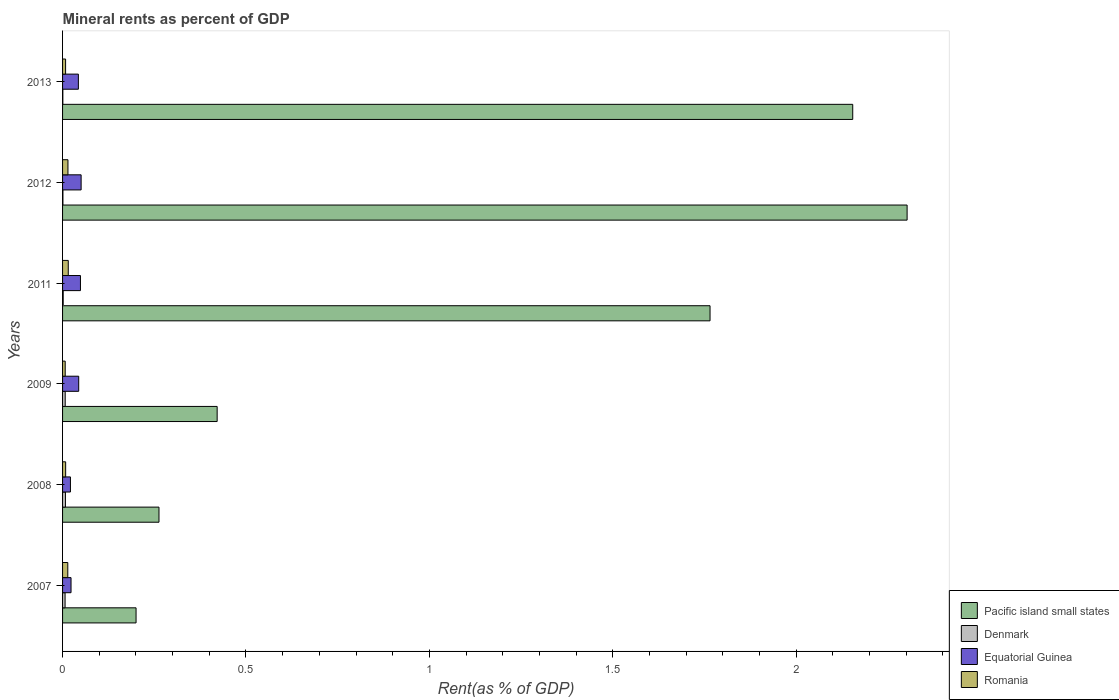Are the number of bars per tick equal to the number of legend labels?
Give a very brief answer. Yes. Are the number of bars on each tick of the Y-axis equal?
Ensure brevity in your answer.  Yes. How many bars are there on the 6th tick from the bottom?
Offer a very short reply. 4. What is the mineral rent in Pacific island small states in 2013?
Your response must be concise. 2.15. Across all years, what is the maximum mineral rent in Equatorial Guinea?
Offer a terse response. 0.05. Across all years, what is the minimum mineral rent in Equatorial Guinea?
Offer a very short reply. 0.02. In which year was the mineral rent in Denmark maximum?
Give a very brief answer. 2008. What is the total mineral rent in Denmark in the graph?
Provide a succinct answer. 0.03. What is the difference between the mineral rent in Pacific island small states in 2012 and that in 2013?
Give a very brief answer. 0.15. What is the difference between the mineral rent in Romania in 2009 and the mineral rent in Pacific island small states in 2007?
Your answer should be very brief. -0.19. What is the average mineral rent in Pacific island small states per year?
Offer a very short reply. 1.18. In the year 2008, what is the difference between the mineral rent in Pacific island small states and mineral rent in Equatorial Guinea?
Offer a very short reply. 0.24. In how many years, is the mineral rent in Equatorial Guinea greater than 1 %?
Provide a succinct answer. 0. What is the ratio of the mineral rent in Pacific island small states in 2011 to that in 2013?
Your answer should be compact. 0.82. What is the difference between the highest and the second highest mineral rent in Equatorial Guinea?
Your answer should be very brief. 0. What is the difference between the highest and the lowest mineral rent in Romania?
Your answer should be very brief. 0.01. Is the sum of the mineral rent in Equatorial Guinea in 2008 and 2009 greater than the maximum mineral rent in Denmark across all years?
Your response must be concise. Yes. Is it the case that in every year, the sum of the mineral rent in Equatorial Guinea and mineral rent in Pacific island small states is greater than the sum of mineral rent in Romania and mineral rent in Denmark?
Give a very brief answer. Yes. What does the 1st bar from the top in 2012 represents?
Your answer should be compact. Romania. What does the 1st bar from the bottom in 2007 represents?
Offer a very short reply. Pacific island small states. How many bars are there?
Provide a succinct answer. 24. How many years are there in the graph?
Offer a terse response. 6. Are the values on the major ticks of X-axis written in scientific E-notation?
Provide a short and direct response. No. Does the graph contain grids?
Provide a short and direct response. No. Where does the legend appear in the graph?
Make the answer very short. Bottom right. What is the title of the graph?
Keep it short and to the point. Mineral rents as percent of GDP. What is the label or title of the X-axis?
Offer a terse response. Rent(as % of GDP). What is the Rent(as % of GDP) in Pacific island small states in 2007?
Make the answer very short. 0.2. What is the Rent(as % of GDP) of Denmark in 2007?
Provide a short and direct response. 0.01. What is the Rent(as % of GDP) of Equatorial Guinea in 2007?
Provide a succinct answer. 0.02. What is the Rent(as % of GDP) of Romania in 2007?
Offer a terse response. 0.01. What is the Rent(as % of GDP) in Pacific island small states in 2008?
Keep it short and to the point. 0.26. What is the Rent(as % of GDP) in Denmark in 2008?
Keep it short and to the point. 0.01. What is the Rent(as % of GDP) of Equatorial Guinea in 2008?
Offer a very short reply. 0.02. What is the Rent(as % of GDP) in Romania in 2008?
Keep it short and to the point. 0.01. What is the Rent(as % of GDP) of Pacific island small states in 2009?
Provide a short and direct response. 0.42. What is the Rent(as % of GDP) in Denmark in 2009?
Provide a succinct answer. 0.01. What is the Rent(as % of GDP) in Equatorial Guinea in 2009?
Provide a short and direct response. 0.04. What is the Rent(as % of GDP) in Romania in 2009?
Ensure brevity in your answer.  0.01. What is the Rent(as % of GDP) of Pacific island small states in 2011?
Offer a very short reply. 1.77. What is the Rent(as % of GDP) in Denmark in 2011?
Provide a succinct answer. 0. What is the Rent(as % of GDP) in Equatorial Guinea in 2011?
Give a very brief answer. 0.05. What is the Rent(as % of GDP) of Romania in 2011?
Ensure brevity in your answer.  0.02. What is the Rent(as % of GDP) in Pacific island small states in 2012?
Your answer should be compact. 2.3. What is the Rent(as % of GDP) in Denmark in 2012?
Keep it short and to the point. 0. What is the Rent(as % of GDP) in Equatorial Guinea in 2012?
Provide a short and direct response. 0.05. What is the Rent(as % of GDP) of Romania in 2012?
Provide a short and direct response. 0.01. What is the Rent(as % of GDP) of Pacific island small states in 2013?
Offer a very short reply. 2.15. What is the Rent(as % of GDP) in Denmark in 2013?
Provide a short and direct response. 0. What is the Rent(as % of GDP) in Equatorial Guinea in 2013?
Offer a very short reply. 0.04. What is the Rent(as % of GDP) of Romania in 2013?
Provide a short and direct response. 0.01. Across all years, what is the maximum Rent(as % of GDP) of Pacific island small states?
Your response must be concise. 2.3. Across all years, what is the maximum Rent(as % of GDP) in Denmark?
Your answer should be very brief. 0.01. Across all years, what is the maximum Rent(as % of GDP) of Equatorial Guinea?
Your answer should be compact. 0.05. Across all years, what is the maximum Rent(as % of GDP) of Romania?
Offer a terse response. 0.02. Across all years, what is the minimum Rent(as % of GDP) in Pacific island small states?
Give a very brief answer. 0.2. Across all years, what is the minimum Rent(as % of GDP) of Denmark?
Your answer should be very brief. 0. Across all years, what is the minimum Rent(as % of GDP) of Equatorial Guinea?
Provide a succinct answer. 0.02. Across all years, what is the minimum Rent(as % of GDP) of Romania?
Provide a succinct answer. 0.01. What is the total Rent(as % of GDP) of Pacific island small states in the graph?
Ensure brevity in your answer.  7.11. What is the total Rent(as % of GDP) in Denmark in the graph?
Your answer should be very brief. 0.03. What is the total Rent(as % of GDP) of Equatorial Guinea in the graph?
Keep it short and to the point. 0.23. What is the total Rent(as % of GDP) in Romania in the graph?
Ensure brevity in your answer.  0.07. What is the difference between the Rent(as % of GDP) of Pacific island small states in 2007 and that in 2008?
Your answer should be very brief. -0.06. What is the difference between the Rent(as % of GDP) of Denmark in 2007 and that in 2008?
Give a very brief answer. -0. What is the difference between the Rent(as % of GDP) of Equatorial Guinea in 2007 and that in 2008?
Keep it short and to the point. 0. What is the difference between the Rent(as % of GDP) of Romania in 2007 and that in 2008?
Give a very brief answer. 0.01. What is the difference between the Rent(as % of GDP) of Pacific island small states in 2007 and that in 2009?
Provide a succinct answer. -0.22. What is the difference between the Rent(as % of GDP) in Denmark in 2007 and that in 2009?
Your answer should be compact. -0. What is the difference between the Rent(as % of GDP) in Equatorial Guinea in 2007 and that in 2009?
Keep it short and to the point. -0.02. What is the difference between the Rent(as % of GDP) of Romania in 2007 and that in 2009?
Ensure brevity in your answer.  0.01. What is the difference between the Rent(as % of GDP) of Pacific island small states in 2007 and that in 2011?
Provide a succinct answer. -1.56. What is the difference between the Rent(as % of GDP) of Denmark in 2007 and that in 2011?
Provide a short and direct response. 0.01. What is the difference between the Rent(as % of GDP) in Equatorial Guinea in 2007 and that in 2011?
Ensure brevity in your answer.  -0.03. What is the difference between the Rent(as % of GDP) in Romania in 2007 and that in 2011?
Offer a terse response. -0. What is the difference between the Rent(as % of GDP) of Pacific island small states in 2007 and that in 2012?
Offer a very short reply. -2.1. What is the difference between the Rent(as % of GDP) of Denmark in 2007 and that in 2012?
Give a very brief answer. 0.01. What is the difference between the Rent(as % of GDP) of Equatorial Guinea in 2007 and that in 2012?
Offer a very short reply. -0.03. What is the difference between the Rent(as % of GDP) of Romania in 2007 and that in 2012?
Offer a terse response. -0. What is the difference between the Rent(as % of GDP) in Pacific island small states in 2007 and that in 2013?
Give a very brief answer. -1.95. What is the difference between the Rent(as % of GDP) of Denmark in 2007 and that in 2013?
Keep it short and to the point. 0.01. What is the difference between the Rent(as % of GDP) of Equatorial Guinea in 2007 and that in 2013?
Keep it short and to the point. -0.02. What is the difference between the Rent(as % of GDP) of Romania in 2007 and that in 2013?
Your answer should be very brief. 0.01. What is the difference between the Rent(as % of GDP) in Pacific island small states in 2008 and that in 2009?
Offer a terse response. -0.16. What is the difference between the Rent(as % of GDP) of Denmark in 2008 and that in 2009?
Make the answer very short. 0. What is the difference between the Rent(as % of GDP) of Equatorial Guinea in 2008 and that in 2009?
Offer a terse response. -0.02. What is the difference between the Rent(as % of GDP) in Romania in 2008 and that in 2009?
Your response must be concise. 0. What is the difference between the Rent(as % of GDP) in Pacific island small states in 2008 and that in 2011?
Keep it short and to the point. -1.5. What is the difference between the Rent(as % of GDP) of Denmark in 2008 and that in 2011?
Your answer should be compact. 0.01. What is the difference between the Rent(as % of GDP) of Equatorial Guinea in 2008 and that in 2011?
Keep it short and to the point. -0.03. What is the difference between the Rent(as % of GDP) of Romania in 2008 and that in 2011?
Offer a very short reply. -0.01. What is the difference between the Rent(as % of GDP) of Pacific island small states in 2008 and that in 2012?
Give a very brief answer. -2.04. What is the difference between the Rent(as % of GDP) of Denmark in 2008 and that in 2012?
Keep it short and to the point. 0.01. What is the difference between the Rent(as % of GDP) in Equatorial Guinea in 2008 and that in 2012?
Your answer should be very brief. -0.03. What is the difference between the Rent(as % of GDP) of Romania in 2008 and that in 2012?
Keep it short and to the point. -0.01. What is the difference between the Rent(as % of GDP) in Pacific island small states in 2008 and that in 2013?
Your answer should be compact. -1.89. What is the difference between the Rent(as % of GDP) in Denmark in 2008 and that in 2013?
Provide a short and direct response. 0.01. What is the difference between the Rent(as % of GDP) of Equatorial Guinea in 2008 and that in 2013?
Give a very brief answer. -0.02. What is the difference between the Rent(as % of GDP) in Pacific island small states in 2009 and that in 2011?
Make the answer very short. -1.34. What is the difference between the Rent(as % of GDP) of Denmark in 2009 and that in 2011?
Your answer should be very brief. 0.01. What is the difference between the Rent(as % of GDP) of Equatorial Guinea in 2009 and that in 2011?
Offer a terse response. -0. What is the difference between the Rent(as % of GDP) in Romania in 2009 and that in 2011?
Offer a terse response. -0.01. What is the difference between the Rent(as % of GDP) in Pacific island small states in 2009 and that in 2012?
Your response must be concise. -1.88. What is the difference between the Rent(as % of GDP) of Denmark in 2009 and that in 2012?
Keep it short and to the point. 0.01. What is the difference between the Rent(as % of GDP) in Equatorial Guinea in 2009 and that in 2012?
Your answer should be very brief. -0.01. What is the difference between the Rent(as % of GDP) in Romania in 2009 and that in 2012?
Keep it short and to the point. -0.01. What is the difference between the Rent(as % of GDP) in Pacific island small states in 2009 and that in 2013?
Give a very brief answer. -1.73. What is the difference between the Rent(as % of GDP) in Denmark in 2009 and that in 2013?
Offer a terse response. 0.01. What is the difference between the Rent(as % of GDP) of Equatorial Guinea in 2009 and that in 2013?
Your response must be concise. 0. What is the difference between the Rent(as % of GDP) in Romania in 2009 and that in 2013?
Ensure brevity in your answer.  -0. What is the difference between the Rent(as % of GDP) of Pacific island small states in 2011 and that in 2012?
Provide a succinct answer. -0.54. What is the difference between the Rent(as % of GDP) of Denmark in 2011 and that in 2012?
Your response must be concise. 0. What is the difference between the Rent(as % of GDP) of Equatorial Guinea in 2011 and that in 2012?
Give a very brief answer. -0. What is the difference between the Rent(as % of GDP) in Romania in 2011 and that in 2012?
Your response must be concise. 0. What is the difference between the Rent(as % of GDP) in Pacific island small states in 2011 and that in 2013?
Give a very brief answer. -0.39. What is the difference between the Rent(as % of GDP) in Denmark in 2011 and that in 2013?
Offer a very short reply. 0. What is the difference between the Rent(as % of GDP) of Equatorial Guinea in 2011 and that in 2013?
Provide a short and direct response. 0.01. What is the difference between the Rent(as % of GDP) in Romania in 2011 and that in 2013?
Your answer should be compact. 0.01. What is the difference between the Rent(as % of GDP) in Pacific island small states in 2012 and that in 2013?
Offer a terse response. 0.15. What is the difference between the Rent(as % of GDP) of Equatorial Guinea in 2012 and that in 2013?
Provide a short and direct response. 0.01. What is the difference between the Rent(as % of GDP) of Romania in 2012 and that in 2013?
Your answer should be compact. 0.01. What is the difference between the Rent(as % of GDP) in Pacific island small states in 2007 and the Rent(as % of GDP) in Denmark in 2008?
Keep it short and to the point. 0.19. What is the difference between the Rent(as % of GDP) of Pacific island small states in 2007 and the Rent(as % of GDP) of Equatorial Guinea in 2008?
Provide a succinct answer. 0.18. What is the difference between the Rent(as % of GDP) in Pacific island small states in 2007 and the Rent(as % of GDP) in Romania in 2008?
Offer a terse response. 0.19. What is the difference between the Rent(as % of GDP) of Denmark in 2007 and the Rent(as % of GDP) of Equatorial Guinea in 2008?
Your response must be concise. -0.01. What is the difference between the Rent(as % of GDP) of Denmark in 2007 and the Rent(as % of GDP) of Romania in 2008?
Keep it short and to the point. -0. What is the difference between the Rent(as % of GDP) in Equatorial Guinea in 2007 and the Rent(as % of GDP) in Romania in 2008?
Provide a short and direct response. 0.01. What is the difference between the Rent(as % of GDP) in Pacific island small states in 2007 and the Rent(as % of GDP) in Denmark in 2009?
Your answer should be compact. 0.19. What is the difference between the Rent(as % of GDP) in Pacific island small states in 2007 and the Rent(as % of GDP) in Equatorial Guinea in 2009?
Your response must be concise. 0.16. What is the difference between the Rent(as % of GDP) in Pacific island small states in 2007 and the Rent(as % of GDP) in Romania in 2009?
Offer a terse response. 0.19. What is the difference between the Rent(as % of GDP) in Denmark in 2007 and the Rent(as % of GDP) in Equatorial Guinea in 2009?
Give a very brief answer. -0.04. What is the difference between the Rent(as % of GDP) in Denmark in 2007 and the Rent(as % of GDP) in Romania in 2009?
Your answer should be compact. -0. What is the difference between the Rent(as % of GDP) of Equatorial Guinea in 2007 and the Rent(as % of GDP) of Romania in 2009?
Offer a terse response. 0.02. What is the difference between the Rent(as % of GDP) of Pacific island small states in 2007 and the Rent(as % of GDP) of Denmark in 2011?
Your answer should be compact. 0.2. What is the difference between the Rent(as % of GDP) in Pacific island small states in 2007 and the Rent(as % of GDP) in Equatorial Guinea in 2011?
Give a very brief answer. 0.15. What is the difference between the Rent(as % of GDP) of Pacific island small states in 2007 and the Rent(as % of GDP) of Romania in 2011?
Give a very brief answer. 0.18. What is the difference between the Rent(as % of GDP) of Denmark in 2007 and the Rent(as % of GDP) of Equatorial Guinea in 2011?
Make the answer very short. -0.04. What is the difference between the Rent(as % of GDP) of Denmark in 2007 and the Rent(as % of GDP) of Romania in 2011?
Give a very brief answer. -0.01. What is the difference between the Rent(as % of GDP) of Equatorial Guinea in 2007 and the Rent(as % of GDP) of Romania in 2011?
Your answer should be compact. 0.01. What is the difference between the Rent(as % of GDP) of Pacific island small states in 2007 and the Rent(as % of GDP) of Denmark in 2012?
Make the answer very short. 0.2. What is the difference between the Rent(as % of GDP) in Pacific island small states in 2007 and the Rent(as % of GDP) in Equatorial Guinea in 2012?
Make the answer very short. 0.15. What is the difference between the Rent(as % of GDP) of Pacific island small states in 2007 and the Rent(as % of GDP) of Romania in 2012?
Keep it short and to the point. 0.19. What is the difference between the Rent(as % of GDP) in Denmark in 2007 and the Rent(as % of GDP) in Equatorial Guinea in 2012?
Offer a terse response. -0.04. What is the difference between the Rent(as % of GDP) of Denmark in 2007 and the Rent(as % of GDP) of Romania in 2012?
Offer a terse response. -0.01. What is the difference between the Rent(as % of GDP) in Equatorial Guinea in 2007 and the Rent(as % of GDP) in Romania in 2012?
Offer a very short reply. 0.01. What is the difference between the Rent(as % of GDP) of Pacific island small states in 2007 and the Rent(as % of GDP) of Denmark in 2013?
Make the answer very short. 0.2. What is the difference between the Rent(as % of GDP) of Pacific island small states in 2007 and the Rent(as % of GDP) of Equatorial Guinea in 2013?
Your answer should be compact. 0.16. What is the difference between the Rent(as % of GDP) of Pacific island small states in 2007 and the Rent(as % of GDP) of Romania in 2013?
Your answer should be very brief. 0.19. What is the difference between the Rent(as % of GDP) of Denmark in 2007 and the Rent(as % of GDP) of Equatorial Guinea in 2013?
Make the answer very short. -0.04. What is the difference between the Rent(as % of GDP) of Denmark in 2007 and the Rent(as % of GDP) of Romania in 2013?
Ensure brevity in your answer.  -0. What is the difference between the Rent(as % of GDP) in Equatorial Guinea in 2007 and the Rent(as % of GDP) in Romania in 2013?
Ensure brevity in your answer.  0.01. What is the difference between the Rent(as % of GDP) in Pacific island small states in 2008 and the Rent(as % of GDP) in Denmark in 2009?
Provide a short and direct response. 0.26. What is the difference between the Rent(as % of GDP) in Pacific island small states in 2008 and the Rent(as % of GDP) in Equatorial Guinea in 2009?
Offer a very short reply. 0.22. What is the difference between the Rent(as % of GDP) of Pacific island small states in 2008 and the Rent(as % of GDP) of Romania in 2009?
Give a very brief answer. 0.26. What is the difference between the Rent(as % of GDP) in Denmark in 2008 and the Rent(as % of GDP) in Equatorial Guinea in 2009?
Make the answer very short. -0.04. What is the difference between the Rent(as % of GDP) of Denmark in 2008 and the Rent(as % of GDP) of Romania in 2009?
Offer a very short reply. 0. What is the difference between the Rent(as % of GDP) of Equatorial Guinea in 2008 and the Rent(as % of GDP) of Romania in 2009?
Your answer should be compact. 0.01. What is the difference between the Rent(as % of GDP) in Pacific island small states in 2008 and the Rent(as % of GDP) in Denmark in 2011?
Provide a short and direct response. 0.26. What is the difference between the Rent(as % of GDP) of Pacific island small states in 2008 and the Rent(as % of GDP) of Equatorial Guinea in 2011?
Offer a very short reply. 0.21. What is the difference between the Rent(as % of GDP) in Pacific island small states in 2008 and the Rent(as % of GDP) in Romania in 2011?
Ensure brevity in your answer.  0.25. What is the difference between the Rent(as % of GDP) in Denmark in 2008 and the Rent(as % of GDP) in Equatorial Guinea in 2011?
Provide a succinct answer. -0.04. What is the difference between the Rent(as % of GDP) in Denmark in 2008 and the Rent(as % of GDP) in Romania in 2011?
Your answer should be compact. -0.01. What is the difference between the Rent(as % of GDP) of Equatorial Guinea in 2008 and the Rent(as % of GDP) of Romania in 2011?
Ensure brevity in your answer.  0.01. What is the difference between the Rent(as % of GDP) of Pacific island small states in 2008 and the Rent(as % of GDP) of Denmark in 2012?
Give a very brief answer. 0.26. What is the difference between the Rent(as % of GDP) of Pacific island small states in 2008 and the Rent(as % of GDP) of Equatorial Guinea in 2012?
Ensure brevity in your answer.  0.21. What is the difference between the Rent(as % of GDP) of Pacific island small states in 2008 and the Rent(as % of GDP) of Romania in 2012?
Provide a short and direct response. 0.25. What is the difference between the Rent(as % of GDP) in Denmark in 2008 and the Rent(as % of GDP) in Equatorial Guinea in 2012?
Offer a very short reply. -0.04. What is the difference between the Rent(as % of GDP) of Denmark in 2008 and the Rent(as % of GDP) of Romania in 2012?
Ensure brevity in your answer.  -0.01. What is the difference between the Rent(as % of GDP) in Equatorial Guinea in 2008 and the Rent(as % of GDP) in Romania in 2012?
Provide a succinct answer. 0.01. What is the difference between the Rent(as % of GDP) of Pacific island small states in 2008 and the Rent(as % of GDP) of Denmark in 2013?
Offer a very short reply. 0.26. What is the difference between the Rent(as % of GDP) of Pacific island small states in 2008 and the Rent(as % of GDP) of Equatorial Guinea in 2013?
Ensure brevity in your answer.  0.22. What is the difference between the Rent(as % of GDP) of Pacific island small states in 2008 and the Rent(as % of GDP) of Romania in 2013?
Give a very brief answer. 0.25. What is the difference between the Rent(as % of GDP) of Denmark in 2008 and the Rent(as % of GDP) of Equatorial Guinea in 2013?
Your answer should be compact. -0.04. What is the difference between the Rent(as % of GDP) of Denmark in 2008 and the Rent(as % of GDP) of Romania in 2013?
Give a very brief answer. -0. What is the difference between the Rent(as % of GDP) in Equatorial Guinea in 2008 and the Rent(as % of GDP) in Romania in 2013?
Give a very brief answer. 0.01. What is the difference between the Rent(as % of GDP) in Pacific island small states in 2009 and the Rent(as % of GDP) in Denmark in 2011?
Keep it short and to the point. 0.42. What is the difference between the Rent(as % of GDP) in Pacific island small states in 2009 and the Rent(as % of GDP) in Equatorial Guinea in 2011?
Provide a short and direct response. 0.37. What is the difference between the Rent(as % of GDP) in Pacific island small states in 2009 and the Rent(as % of GDP) in Romania in 2011?
Provide a short and direct response. 0.41. What is the difference between the Rent(as % of GDP) in Denmark in 2009 and the Rent(as % of GDP) in Equatorial Guinea in 2011?
Offer a very short reply. -0.04. What is the difference between the Rent(as % of GDP) in Denmark in 2009 and the Rent(as % of GDP) in Romania in 2011?
Ensure brevity in your answer.  -0.01. What is the difference between the Rent(as % of GDP) in Equatorial Guinea in 2009 and the Rent(as % of GDP) in Romania in 2011?
Provide a short and direct response. 0.03. What is the difference between the Rent(as % of GDP) of Pacific island small states in 2009 and the Rent(as % of GDP) of Denmark in 2012?
Make the answer very short. 0.42. What is the difference between the Rent(as % of GDP) in Pacific island small states in 2009 and the Rent(as % of GDP) in Equatorial Guinea in 2012?
Ensure brevity in your answer.  0.37. What is the difference between the Rent(as % of GDP) of Pacific island small states in 2009 and the Rent(as % of GDP) of Romania in 2012?
Give a very brief answer. 0.41. What is the difference between the Rent(as % of GDP) of Denmark in 2009 and the Rent(as % of GDP) of Equatorial Guinea in 2012?
Ensure brevity in your answer.  -0.04. What is the difference between the Rent(as % of GDP) in Denmark in 2009 and the Rent(as % of GDP) in Romania in 2012?
Provide a succinct answer. -0.01. What is the difference between the Rent(as % of GDP) of Equatorial Guinea in 2009 and the Rent(as % of GDP) of Romania in 2012?
Offer a terse response. 0.03. What is the difference between the Rent(as % of GDP) in Pacific island small states in 2009 and the Rent(as % of GDP) in Denmark in 2013?
Provide a succinct answer. 0.42. What is the difference between the Rent(as % of GDP) of Pacific island small states in 2009 and the Rent(as % of GDP) of Equatorial Guinea in 2013?
Ensure brevity in your answer.  0.38. What is the difference between the Rent(as % of GDP) of Pacific island small states in 2009 and the Rent(as % of GDP) of Romania in 2013?
Your answer should be compact. 0.41. What is the difference between the Rent(as % of GDP) in Denmark in 2009 and the Rent(as % of GDP) in Equatorial Guinea in 2013?
Give a very brief answer. -0.04. What is the difference between the Rent(as % of GDP) of Denmark in 2009 and the Rent(as % of GDP) of Romania in 2013?
Provide a short and direct response. -0. What is the difference between the Rent(as % of GDP) in Equatorial Guinea in 2009 and the Rent(as % of GDP) in Romania in 2013?
Offer a very short reply. 0.04. What is the difference between the Rent(as % of GDP) in Pacific island small states in 2011 and the Rent(as % of GDP) in Denmark in 2012?
Offer a terse response. 1.76. What is the difference between the Rent(as % of GDP) in Pacific island small states in 2011 and the Rent(as % of GDP) in Equatorial Guinea in 2012?
Make the answer very short. 1.71. What is the difference between the Rent(as % of GDP) in Pacific island small states in 2011 and the Rent(as % of GDP) in Romania in 2012?
Your answer should be compact. 1.75. What is the difference between the Rent(as % of GDP) of Denmark in 2011 and the Rent(as % of GDP) of Equatorial Guinea in 2012?
Offer a very short reply. -0.05. What is the difference between the Rent(as % of GDP) in Denmark in 2011 and the Rent(as % of GDP) in Romania in 2012?
Keep it short and to the point. -0.01. What is the difference between the Rent(as % of GDP) of Equatorial Guinea in 2011 and the Rent(as % of GDP) of Romania in 2012?
Your answer should be very brief. 0.03. What is the difference between the Rent(as % of GDP) in Pacific island small states in 2011 and the Rent(as % of GDP) in Denmark in 2013?
Offer a terse response. 1.76. What is the difference between the Rent(as % of GDP) in Pacific island small states in 2011 and the Rent(as % of GDP) in Equatorial Guinea in 2013?
Your response must be concise. 1.72. What is the difference between the Rent(as % of GDP) of Pacific island small states in 2011 and the Rent(as % of GDP) of Romania in 2013?
Ensure brevity in your answer.  1.76. What is the difference between the Rent(as % of GDP) in Denmark in 2011 and the Rent(as % of GDP) in Equatorial Guinea in 2013?
Offer a terse response. -0.04. What is the difference between the Rent(as % of GDP) of Denmark in 2011 and the Rent(as % of GDP) of Romania in 2013?
Ensure brevity in your answer.  -0.01. What is the difference between the Rent(as % of GDP) of Equatorial Guinea in 2011 and the Rent(as % of GDP) of Romania in 2013?
Offer a very short reply. 0.04. What is the difference between the Rent(as % of GDP) in Pacific island small states in 2012 and the Rent(as % of GDP) in Denmark in 2013?
Provide a short and direct response. 2.3. What is the difference between the Rent(as % of GDP) in Pacific island small states in 2012 and the Rent(as % of GDP) in Equatorial Guinea in 2013?
Provide a short and direct response. 2.26. What is the difference between the Rent(as % of GDP) in Pacific island small states in 2012 and the Rent(as % of GDP) in Romania in 2013?
Offer a very short reply. 2.29. What is the difference between the Rent(as % of GDP) in Denmark in 2012 and the Rent(as % of GDP) in Equatorial Guinea in 2013?
Give a very brief answer. -0.04. What is the difference between the Rent(as % of GDP) in Denmark in 2012 and the Rent(as % of GDP) in Romania in 2013?
Make the answer very short. -0.01. What is the difference between the Rent(as % of GDP) of Equatorial Guinea in 2012 and the Rent(as % of GDP) of Romania in 2013?
Provide a short and direct response. 0.04. What is the average Rent(as % of GDP) of Pacific island small states per year?
Your response must be concise. 1.18. What is the average Rent(as % of GDP) of Denmark per year?
Your response must be concise. 0. What is the average Rent(as % of GDP) of Equatorial Guinea per year?
Ensure brevity in your answer.  0.04. What is the average Rent(as % of GDP) in Romania per year?
Your response must be concise. 0.01. In the year 2007, what is the difference between the Rent(as % of GDP) of Pacific island small states and Rent(as % of GDP) of Denmark?
Give a very brief answer. 0.19. In the year 2007, what is the difference between the Rent(as % of GDP) of Pacific island small states and Rent(as % of GDP) of Equatorial Guinea?
Offer a terse response. 0.18. In the year 2007, what is the difference between the Rent(as % of GDP) in Pacific island small states and Rent(as % of GDP) in Romania?
Offer a very short reply. 0.19. In the year 2007, what is the difference between the Rent(as % of GDP) in Denmark and Rent(as % of GDP) in Equatorial Guinea?
Make the answer very short. -0.02. In the year 2007, what is the difference between the Rent(as % of GDP) of Denmark and Rent(as % of GDP) of Romania?
Offer a terse response. -0.01. In the year 2007, what is the difference between the Rent(as % of GDP) of Equatorial Guinea and Rent(as % of GDP) of Romania?
Provide a short and direct response. 0.01. In the year 2008, what is the difference between the Rent(as % of GDP) in Pacific island small states and Rent(as % of GDP) in Denmark?
Offer a terse response. 0.26. In the year 2008, what is the difference between the Rent(as % of GDP) in Pacific island small states and Rent(as % of GDP) in Equatorial Guinea?
Ensure brevity in your answer.  0.24. In the year 2008, what is the difference between the Rent(as % of GDP) of Pacific island small states and Rent(as % of GDP) of Romania?
Make the answer very short. 0.25. In the year 2008, what is the difference between the Rent(as % of GDP) of Denmark and Rent(as % of GDP) of Equatorial Guinea?
Offer a very short reply. -0.01. In the year 2008, what is the difference between the Rent(as % of GDP) of Denmark and Rent(as % of GDP) of Romania?
Your response must be concise. -0. In the year 2008, what is the difference between the Rent(as % of GDP) of Equatorial Guinea and Rent(as % of GDP) of Romania?
Give a very brief answer. 0.01. In the year 2009, what is the difference between the Rent(as % of GDP) in Pacific island small states and Rent(as % of GDP) in Denmark?
Ensure brevity in your answer.  0.41. In the year 2009, what is the difference between the Rent(as % of GDP) of Pacific island small states and Rent(as % of GDP) of Equatorial Guinea?
Ensure brevity in your answer.  0.38. In the year 2009, what is the difference between the Rent(as % of GDP) in Pacific island small states and Rent(as % of GDP) in Romania?
Your answer should be compact. 0.41. In the year 2009, what is the difference between the Rent(as % of GDP) in Denmark and Rent(as % of GDP) in Equatorial Guinea?
Provide a succinct answer. -0.04. In the year 2009, what is the difference between the Rent(as % of GDP) in Denmark and Rent(as % of GDP) in Romania?
Offer a terse response. -0. In the year 2009, what is the difference between the Rent(as % of GDP) in Equatorial Guinea and Rent(as % of GDP) in Romania?
Ensure brevity in your answer.  0.04. In the year 2011, what is the difference between the Rent(as % of GDP) in Pacific island small states and Rent(as % of GDP) in Denmark?
Your answer should be compact. 1.76. In the year 2011, what is the difference between the Rent(as % of GDP) in Pacific island small states and Rent(as % of GDP) in Equatorial Guinea?
Make the answer very short. 1.72. In the year 2011, what is the difference between the Rent(as % of GDP) of Pacific island small states and Rent(as % of GDP) of Romania?
Offer a terse response. 1.75. In the year 2011, what is the difference between the Rent(as % of GDP) in Denmark and Rent(as % of GDP) in Equatorial Guinea?
Make the answer very short. -0.05. In the year 2011, what is the difference between the Rent(as % of GDP) in Denmark and Rent(as % of GDP) in Romania?
Offer a terse response. -0.01. In the year 2011, what is the difference between the Rent(as % of GDP) in Equatorial Guinea and Rent(as % of GDP) in Romania?
Give a very brief answer. 0.03. In the year 2012, what is the difference between the Rent(as % of GDP) in Pacific island small states and Rent(as % of GDP) in Denmark?
Your response must be concise. 2.3. In the year 2012, what is the difference between the Rent(as % of GDP) of Pacific island small states and Rent(as % of GDP) of Equatorial Guinea?
Ensure brevity in your answer.  2.25. In the year 2012, what is the difference between the Rent(as % of GDP) in Pacific island small states and Rent(as % of GDP) in Romania?
Ensure brevity in your answer.  2.29. In the year 2012, what is the difference between the Rent(as % of GDP) in Denmark and Rent(as % of GDP) in Equatorial Guinea?
Your answer should be very brief. -0.05. In the year 2012, what is the difference between the Rent(as % of GDP) of Denmark and Rent(as % of GDP) of Romania?
Offer a very short reply. -0.01. In the year 2012, what is the difference between the Rent(as % of GDP) in Equatorial Guinea and Rent(as % of GDP) in Romania?
Your response must be concise. 0.04. In the year 2013, what is the difference between the Rent(as % of GDP) in Pacific island small states and Rent(as % of GDP) in Denmark?
Your answer should be very brief. 2.15. In the year 2013, what is the difference between the Rent(as % of GDP) of Pacific island small states and Rent(as % of GDP) of Equatorial Guinea?
Your answer should be very brief. 2.11. In the year 2013, what is the difference between the Rent(as % of GDP) in Pacific island small states and Rent(as % of GDP) in Romania?
Give a very brief answer. 2.15. In the year 2013, what is the difference between the Rent(as % of GDP) in Denmark and Rent(as % of GDP) in Equatorial Guinea?
Make the answer very short. -0.04. In the year 2013, what is the difference between the Rent(as % of GDP) of Denmark and Rent(as % of GDP) of Romania?
Keep it short and to the point. -0.01. In the year 2013, what is the difference between the Rent(as % of GDP) in Equatorial Guinea and Rent(as % of GDP) in Romania?
Give a very brief answer. 0.03. What is the ratio of the Rent(as % of GDP) of Pacific island small states in 2007 to that in 2008?
Give a very brief answer. 0.76. What is the ratio of the Rent(as % of GDP) of Denmark in 2007 to that in 2008?
Provide a short and direct response. 0.88. What is the ratio of the Rent(as % of GDP) of Equatorial Guinea in 2007 to that in 2008?
Give a very brief answer. 1.08. What is the ratio of the Rent(as % of GDP) in Romania in 2007 to that in 2008?
Your answer should be very brief. 1.69. What is the ratio of the Rent(as % of GDP) of Pacific island small states in 2007 to that in 2009?
Ensure brevity in your answer.  0.48. What is the ratio of the Rent(as % of GDP) of Denmark in 2007 to that in 2009?
Offer a terse response. 0.96. What is the ratio of the Rent(as % of GDP) in Equatorial Guinea in 2007 to that in 2009?
Your answer should be very brief. 0.53. What is the ratio of the Rent(as % of GDP) of Romania in 2007 to that in 2009?
Give a very brief answer. 1.99. What is the ratio of the Rent(as % of GDP) in Pacific island small states in 2007 to that in 2011?
Provide a succinct answer. 0.11. What is the ratio of the Rent(as % of GDP) in Denmark in 2007 to that in 2011?
Provide a short and direct response. 3.99. What is the ratio of the Rent(as % of GDP) of Equatorial Guinea in 2007 to that in 2011?
Ensure brevity in your answer.  0.47. What is the ratio of the Rent(as % of GDP) in Romania in 2007 to that in 2011?
Your response must be concise. 0.92. What is the ratio of the Rent(as % of GDP) of Pacific island small states in 2007 to that in 2012?
Your answer should be very brief. 0.09. What is the ratio of the Rent(as % of GDP) of Denmark in 2007 to that in 2012?
Offer a terse response. 6.93. What is the ratio of the Rent(as % of GDP) of Equatorial Guinea in 2007 to that in 2012?
Offer a very short reply. 0.46. What is the ratio of the Rent(as % of GDP) in Romania in 2007 to that in 2012?
Your answer should be very brief. 0.97. What is the ratio of the Rent(as % of GDP) in Pacific island small states in 2007 to that in 2013?
Offer a terse response. 0.09. What is the ratio of the Rent(as % of GDP) of Denmark in 2007 to that in 2013?
Keep it short and to the point. 8.97. What is the ratio of the Rent(as % of GDP) in Equatorial Guinea in 2007 to that in 2013?
Provide a short and direct response. 0.54. What is the ratio of the Rent(as % of GDP) in Romania in 2007 to that in 2013?
Your response must be concise. 1.73. What is the ratio of the Rent(as % of GDP) in Pacific island small states in 2008 to that in 2009?
Your answer should be very brief. 0.62. What is the ratio of the Rent(as % of GDP) of Denmark in 2008 to that in 2009?
Your response must be concise. 1.09. What is the ratio of the Rent(as % of GDP) of Equatorial Guinea in 2008 to that in 2009?
Provide a short and direct response. 0.49. What is the ratio of the Rent(as % of GDP) of Romania in 2008 to that in 2009?
Give a very brief answer. 1.17. What is the ratio of the Rent(as % of GDP) in Pacific island small states in 2008 to that in 2011?
Offer a terse response. 0.15. What is the ratio of the Rent(as % of GDP) in Denmark in 2008 to that in 2011?
Offer a very short reply. 4.56. What is the ratio of the Rent(as % of GDP) in Equatorial Guinea in 2008 to that in 2011?
Ensure brevity in your answer.  0.44. What is the ratio of the Rent(as % of GDP) in Romania in 2008 to that in 2011?
Your response must be concise. 0.54. What is the ratio of the Rent(as % of GDP) in Pacific island small states in 2008 to that in 2012?
Provide a succinct answer. 0.11. What is the ratio of the Rent(as % of GDP) of Denmark in 2008 to that in 2012?
Provide a succinct answer. 7.91. What is the ratio of the Rent(as % of GDP) of Equatorial Guinea in 2008 to that in 2012?
Provide a succinct answer. 0.42. What is the ratio of the Rent(as % of GDP) of Romania in 2008 to that in 2012?
Give a very brief answer. 0.57. What is the ratio of the Rent(as % of GDP) in Pacific island small states in 2008 to that in 2013?
Keep it short and to the point. 0.12. What is the ratio of the Rent(as % of GDP) of Denmark in 2008 to that in 2013?
Offer a very short reply. 10.24. What is the ratio of the Rent(as % of GDP) in Equatorial Guinea in 2008 to that in 2013?
Your answer should be very brief. 0.5. What is the ratio of the Rent(as % of GDP) in Romania in 2008 to that in 2013?
Keep it short and to the point. 1.02. What is the ratio of the Rent(as % of GDP) of Pacific island small states in 2009 to that in 2011?
Your answer should be very brief. 0.24. What is the ratio of the Rent(as % of GDP) in Denmark in 2009 to that in 2011?
Provide a short and direct response. 4.18. What is the ratio of the Rent(as % of GDP) in Equatorial Guinea in 2009 to that in 2011?
Offer a terse response. 0.9. What is the ratio of the Rent(as % of GDP) of Romania in 2009 to that in 2011?
Your answer should be very brief. 0.46. What is the ratio of the Rent(as % of GDP) of Pacific island small states in 2009 to that in 2012?
Provide a short and direct response. 0.18. What is the ratio of the Rent(as % of GDP) in Denmark in 2009 to that in 2012?
Your answer should be compact. 7.25. What is the ratio of the Rent(as % of GDP) in Equatorial Guinea in 2009 to that in 2012?
Make the answer very short. 0.87. What is the ratio of the Rent(as % of GDP) in Romania in 2009 to that in 2012?
Provide a short and direct response. 0.49. What is the ratio of the Rent(as % of GDP) of Pacific island small states in 2009 to that in 2013?
Ensure brevity in your answer.  0.2. What is the ratio of the Rent(as % of GDP) of Denmark in 2009 to that in 2013?
Offer a terse response. 9.38. What is the ratio of the Rent(as % of GDP) in Equatorial Guinea in 2009 to that in 2013?
Provide a short and direct response. 1.02. What is the ratio of the Rent(as % of GDP) of Romania in 2009 to that in 2013?
Your response must be concise. 0.87. What is the ratio of the Rent(as % of GDP) in Pacific island small states in 2011 to that in 2012?
Provide a succinct answer. 0.77. What is the ratio of the Rent(as % of GDP) in Denmark in 2011 to that in 2012?
Your answer should be compact. 1.73. What is the ratio of the Rent(as % of GDP) of Equatorial Guinea in 2011 to that in 2012?
Make the answer very short. 0.96. What is the ratio of the Rent(as % of GDP) in Romania in 2011 to that in 2012?
Give a very brief answer. 1.06. What is the ratio of the Rent(as % of GDP) of Pacific island small states in 2011 to that in 2013?
Offer a very short reply. 0.82. What is the ratio of the Rent(as % of GDP) in Denmark in 2011 to that in 2013?
Your answer should be compact. 2.25. What is the ratio of the Rent(as % of GDP) of Equatorial Guinea in 2011 to that in 2013?
Offer a terse response. 1.13. What is the ratio of the Rent(as % of GDP) of Romania in 2011 to that in 2013?
Give a very brief answer. 1.88. What is the ratio of the Rent(as % of GDP) of Pacific island small states in 2012 to that in 2013?
Provide a succinct answer. 1.07. What is the ratio of the Rent(as % of GDP) in Denmark in 2012 to that in 2013?
Make the answer very short. 1.29. What is the ratio of the Rent(as % of GDP) in Equatorial Guinea in 2012 to that in 2013?
Your answer should be very brief. 1.17. What is the ratio of the Rent(as % of GDP) of Romania in 2012 to that in 2013?
Keep it short and to the point. 1.78. What is the difference between the highest and the second highest Rent(as % of GDP) in Pacific island small states?
Ensure brevity in your answer.  0.15. What is the difference between the highest and the second highest Rent(as % of GDP) of Denmark?
Offer a very short reply. 0. What is the difference between the highest and the second highest Rent(as % of GDP) in Equatorial Guinea?
Make the answer very short. 0. What is the difference between the highest and the second highest Rent(as % of GDP) in Romania?
Give a very brief answer. 0. What is the difference between the highest and the lowest Rent(as % of GDP) in Pacific island small states?
Offer a very short reply. 2.1. What is the difference between the highest and the lowest Rent(as % of GDP) in Denmark?
Offer a very short reply. 0.01. What is the difference between the highest and the lowest Rent(as % of GDP) in Equatorial Guinea?
Provide a short and direct response. 0.03. What is the difference between the highest and the lowest Rent(as % of GDP) in Romania?
Offer a terse response. 0.01. 